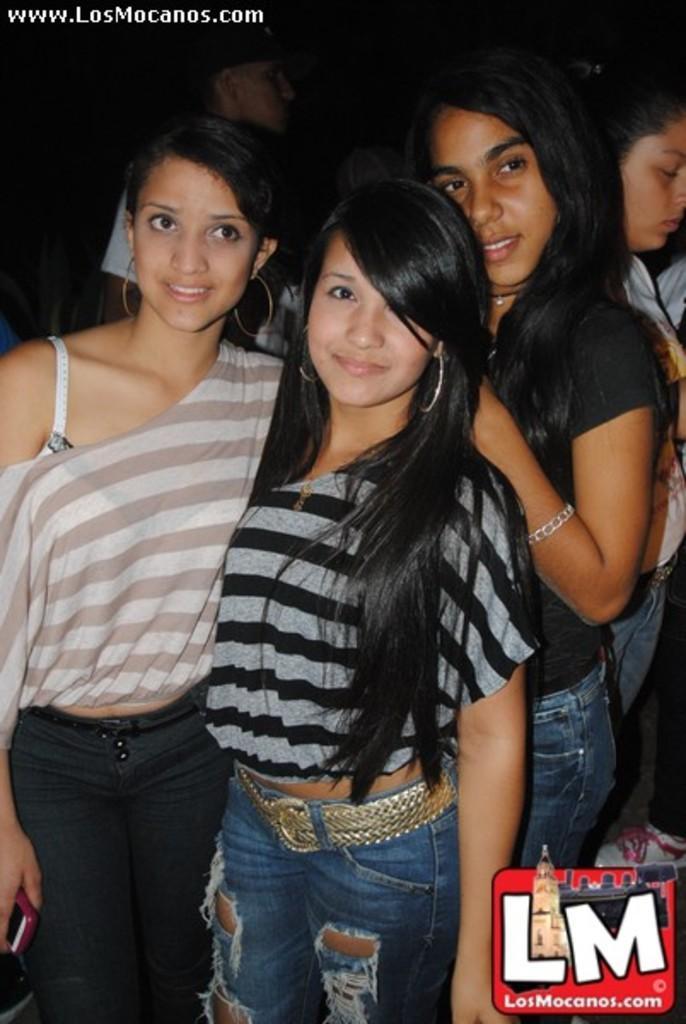Please provide a concise description of this image. There are three women posing to a camera. There is a dark background and we can see two persons. This is a logo. 